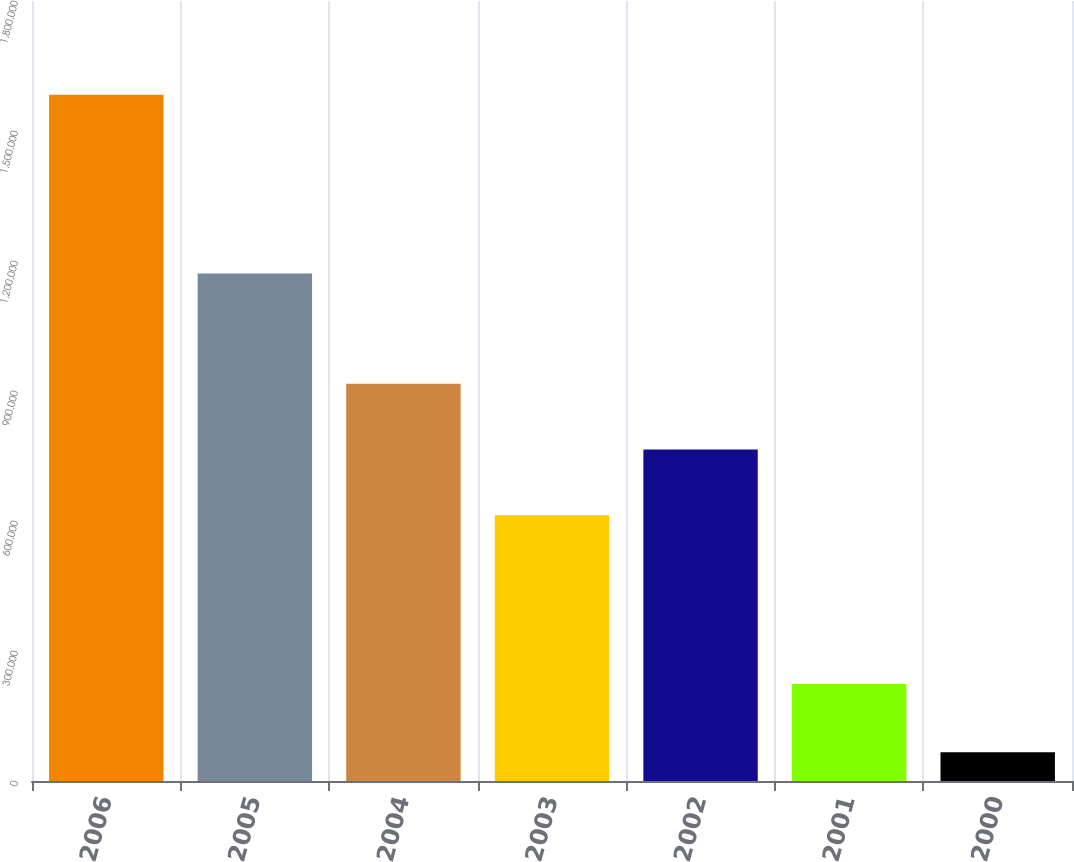Convert chart to OTSL. <chart><loc_0><loc_0><loc_500><loc_500><bar_chart><fcel>2006<fcel>2005<fcel>2004<fcel>2003<fcel>2002<fcel>2001<fcel>2000<nl><fcel>1.5836e+06<fcel>1.1714e+06<fcel>916590<fcel>613100<fcel>764845<fcel>223800<fcel>66150<nl></chart> 